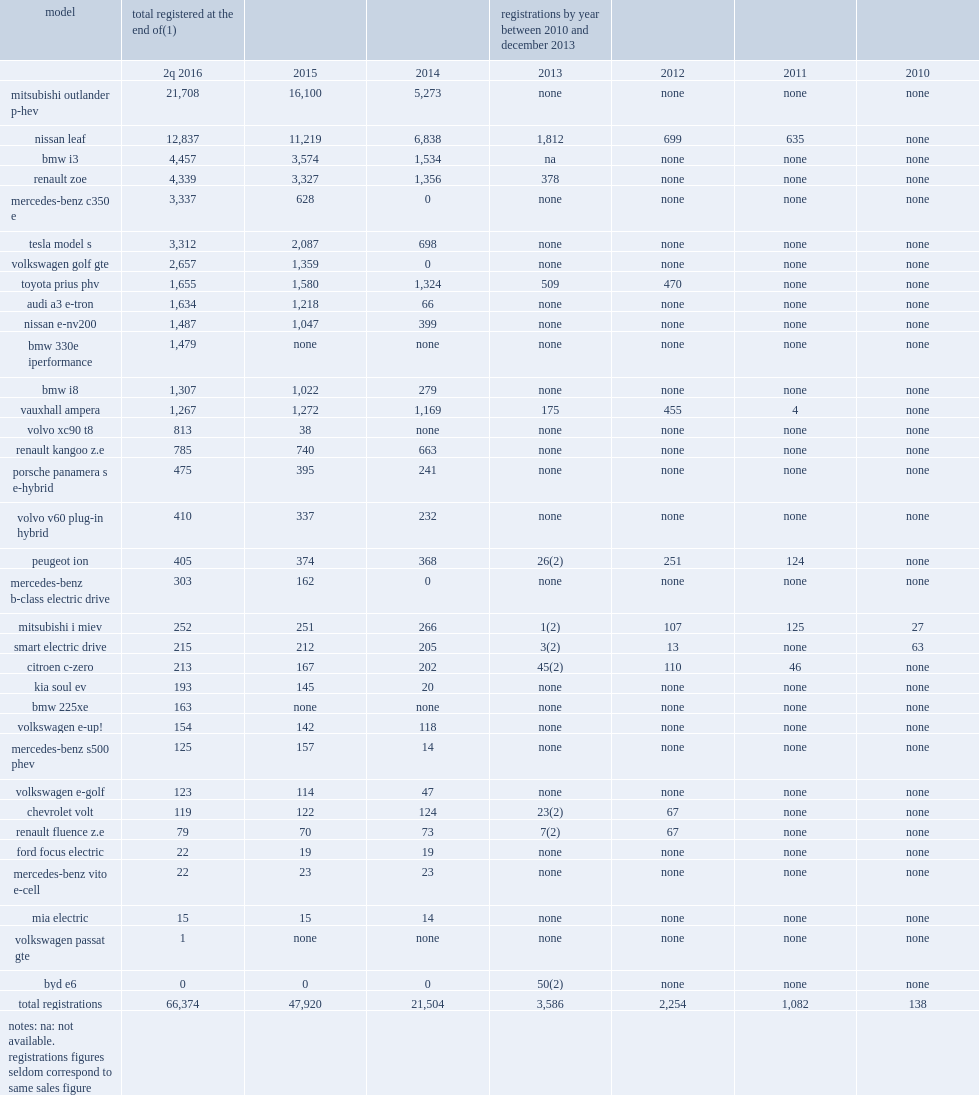How many units did the nissan leaf sell in 2013? 1812.0. 